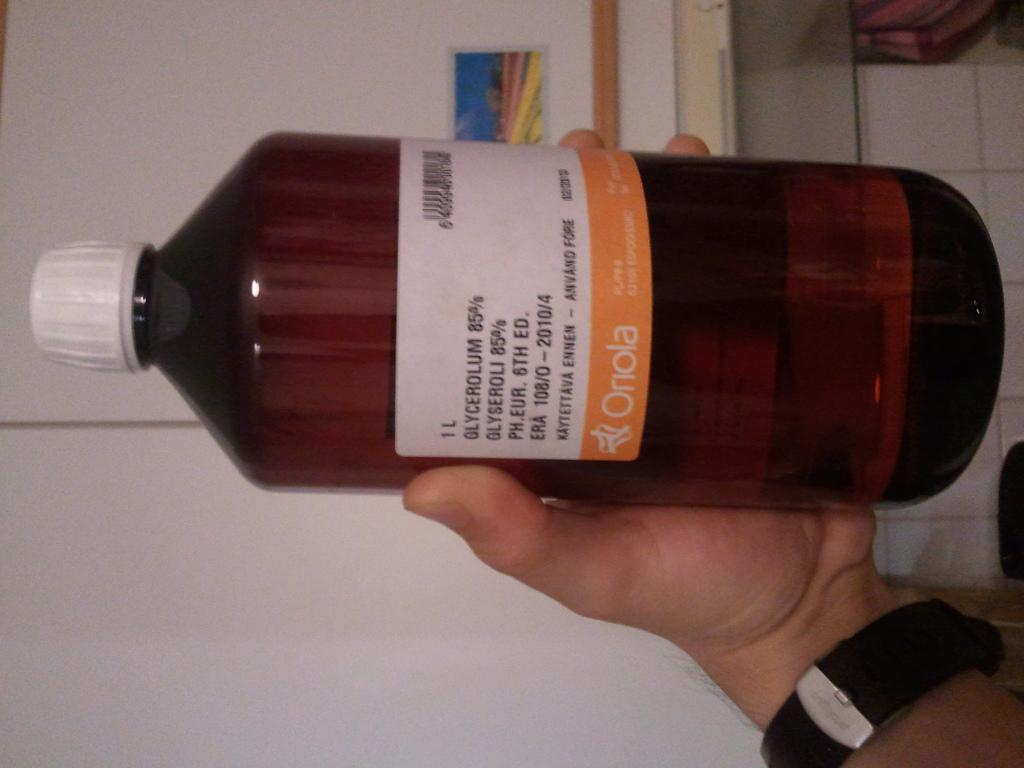<image>
Relay a brief, clear account of the picture shown. a bottle with an orange and white label that says 'onola' on it 